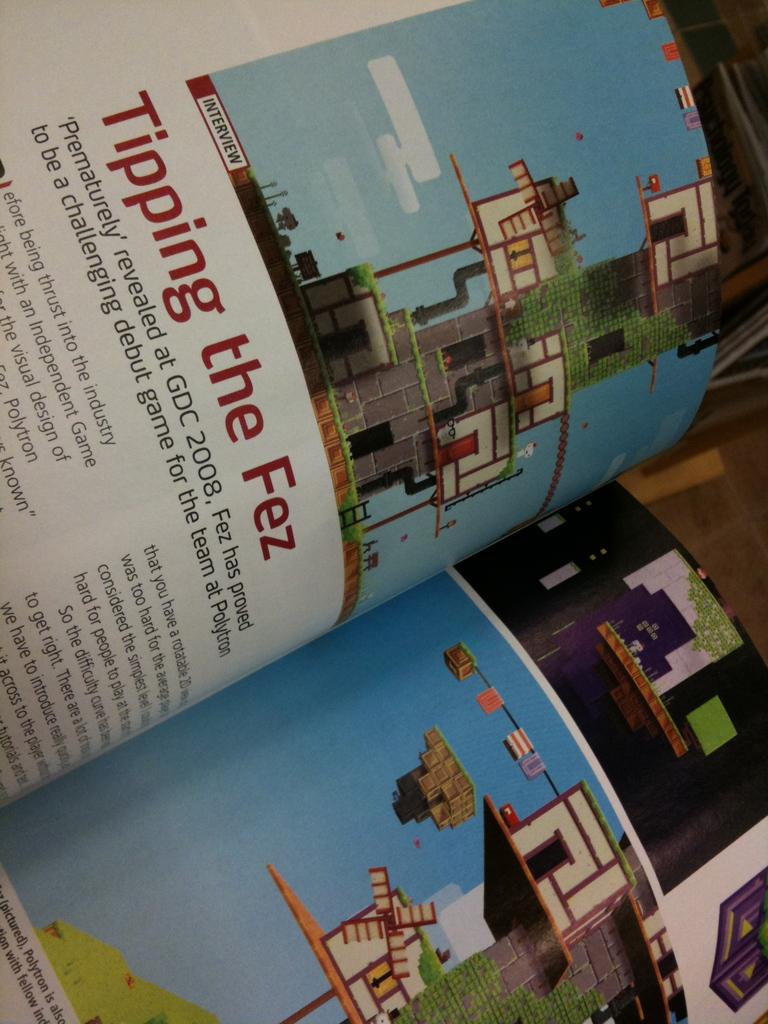<image>
Offer a succinct explanation of the picture presented. A book opened to a page regarding the game Fez 